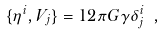<formula> <loc_0><loc_0><loc_500><loc_500>\{ \eta ^ { i } , V _ { j } \} = 1 2 \pi G \gamma \delta _ { j } ^ { i } \ ,</formula> 